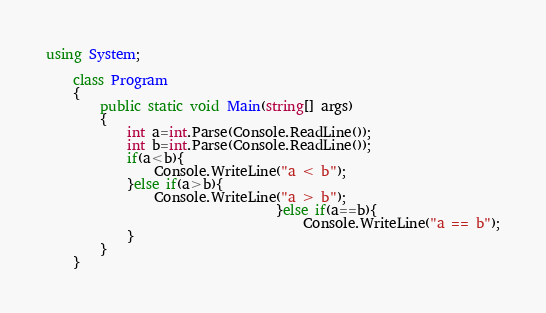<code> <loc_0><loc_0><loc_500><loc_500><_C#_>using System;

    class Program
    {
        public static void Main(string[] args)
        {
            int a=int.Parse(Console.ReadLine());
            int b=int.Parse(Console.ReadLine());
            if(a<b){
                Console.WriteLine("a < b");
            }else if(a>b){
                Console.WriteLine("a > b");
                                  }else if(a==b){
                                      Console.WriteLine("a == b");
            }
        }
    }

</code> 